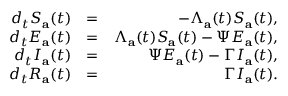<formula> <loc_0><loc_0><loc_500><loc_500>\begin{array} { r l r } { d _ { t } S _ { a } ( t ) } & { = } & { - \Lambda _ { a } ( t ) S _ { a } ( t ) , } \\ { d _ { t } E _ { a } ( t ) } & { = } & { \Lambda _ { a } ( t ) S _ { a } ( t ) - \Psi E _ { a } ( t ) , } \\ { d _ { t } I _ { a } ( t ) } & { = } & { \Psi E _ { a } ( t ) - \Gamma I _ { a } ( t ) , } \\ { d _ { t } R _ { a } ( t ) } & { = } & { \Gamma I _ { a } ( t ) . } \end{array}</formula> 